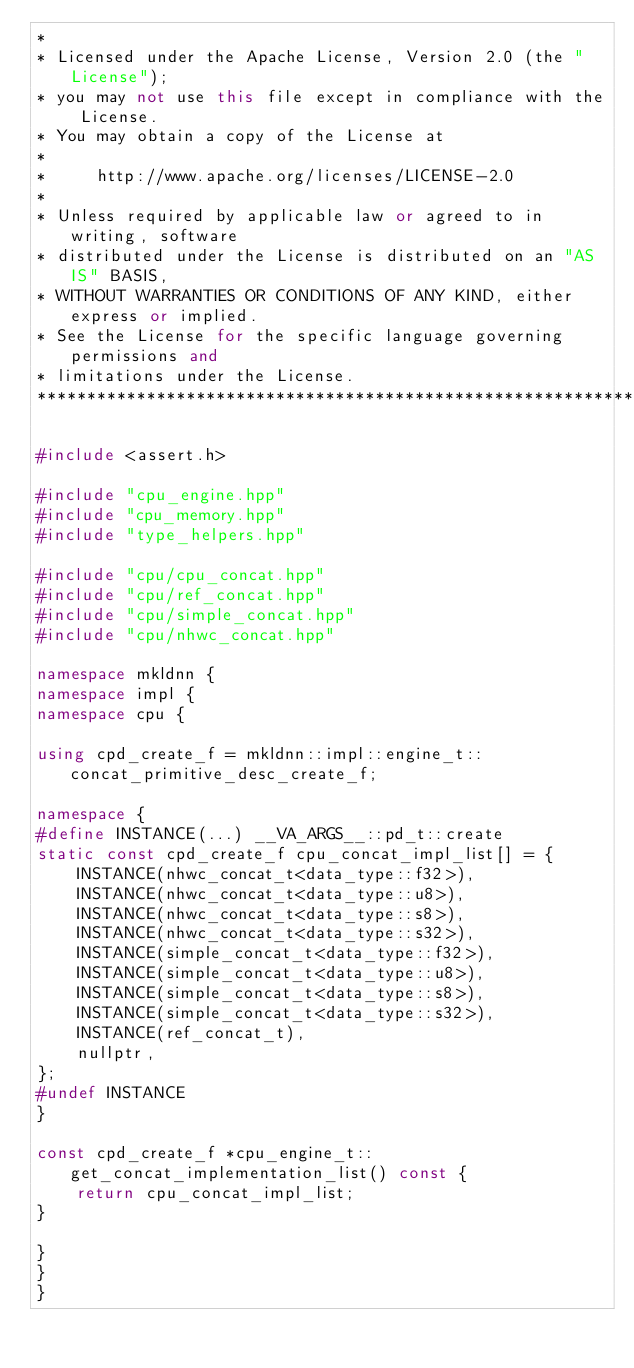Convert code to text. <code><loc_0><loc_0><loc_500><loc_500><_C++_>*
* Licensed under the Apache License, Version 2.0 (the "License");
* you may not use this file except in compliance with the License.
* You may obtain a copy of the License at
*
*     http://www.apache.org/licenses/LICENSE-2.0
*
* Unless required by applicable law or agreed to in writing, software
* distributed under the License is distributed on an "AS IS" BASIS,
* WITHOUT WARRANTIES OR CONDITIONS OF ANY KIND, either express or implied.
* See the License for the specific language governing permissions and
* limitations under the License.
*******************************************************************************/

#include <assert.h>

#include "cpu_engine.hpp"
#include "cpu_memory.hpp"
#include "type_helpers.hpp"

#include "cpu/cpu_concat.hpp"
#include "cpu/ref_concat.hpp"
#include "cpu/simple_concat.hpp"
#include "cpu/nhwc_concat.hpp"

namespace mkldnn {
namespace impl {
namespace cpu {

using cpd_create_f = mkldnn::impl::engine_t::concat_primitive_desc_create_f;

namespace {
#define INSTANCE(...) __VA_ARGS__::pd_t::create
static const cpd_create_f cpu_concat_impl_list[] = {
    INSTANCE(nhwc_concat_t<data_type::f32>),
    INSTANCE(nhwc_concat_t<data_type::u8>),
    INSTANCE(nhwc_concat_t<data_type::s8>),
    INSTANCE(nhwc_concat_t<data_type::s32>),
    INSTANCE(simple_concat_t<data_type::f32>),
    INSTANCE(simple_concat_t<data_type::u8>),
    INSTANCE(simple_concat_t<data_type::s8>),
    INSTANCE(simple_concat_t<data_type::s32>),
    INSTANCE(ref_concat_t),
    nullptr,
};
#undef INSTANCE
}

const cpd_create_f *cpu_engine_t::get_concat_implementation_list() const {
    return cpu_concat_impl_list;
}

}
}
}
</code> 